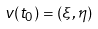<formula> <loc_0><loc_0><loc_500><loc_500>v ( t _ { 0 } ) = ( \xi , \eta )</formula> 